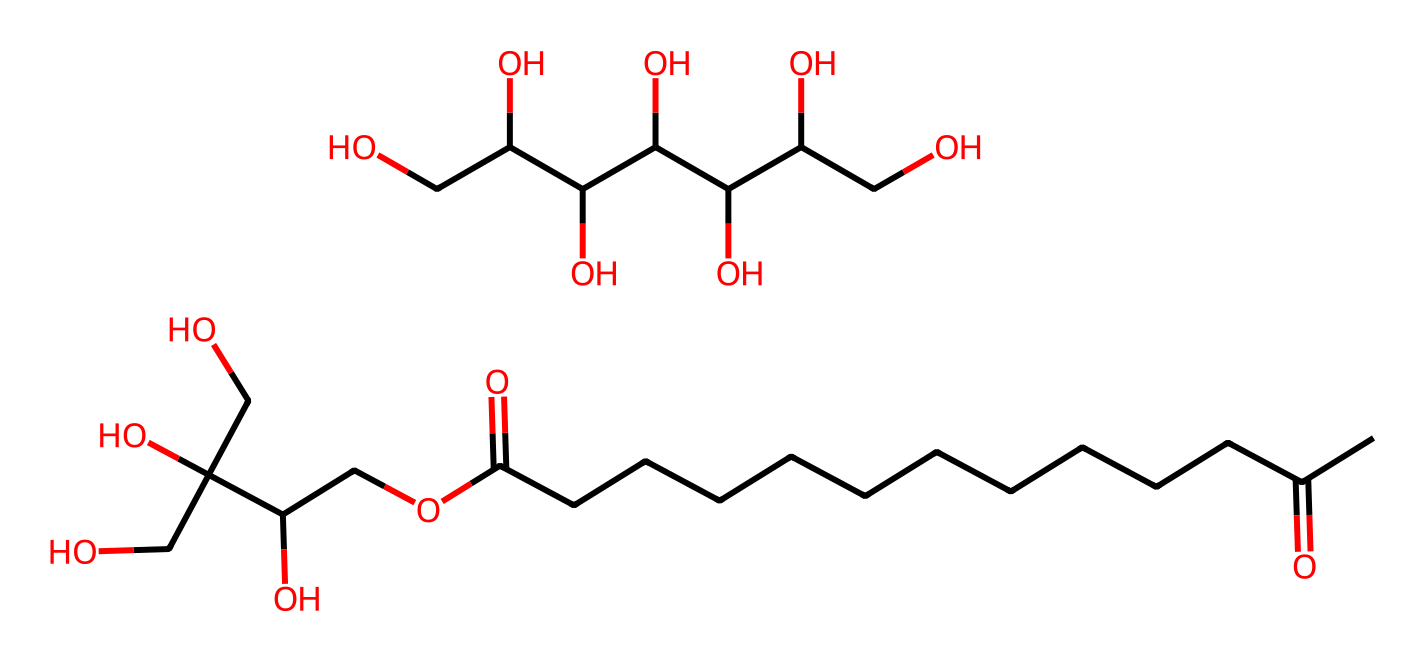What is the main functional group present in polysorbate 20? The structure contains multiple hydroxyl (OH) groups and ester functional groups, which are indicative of a polysorbate. The presence of these groups is critical for its surfactant properties.
Answer: hydroxyl and ester How many carbon atoms are in the primary hydrocarbon chain? Analyzing the structure reveals 11 carbon atoms in the long hydrocarbon chain, which is characteristic of surfactants that help reduce surface tension.
Answer: 11 What is the total number of oxygen atoms in this molecule? By examining the chemical structure, there are seven oxygen atoms identified: six from hydroxyl groups and one from the ester functional group.
Answer: seven What type of surfactant is polysorbate 20 classified as? Polysorbate 20 is classified based on its ability to stabilize emulsions and foams due to the presence of both hydrophilic and hydrophobic regions in its molecular structure.
Answer: nonionic How does the presence of multiple hydroxyl groups affect the solubility of polysorbate 20? Multiple hydroxyl groups provide strong hydrophilic characteristics, allowing polysorbate 20 to dissolve well in water, thereby enhancing its effectiveness as a surfactant.
Answer: increased solubility What role does the hydrophobic tail of polysorbate 20 play in its function as a surfactant? The hydrophobic tail reduces surface tension and stabilizes emulsions by orienting itself away from water, which is essential for creating stable fog outputs in machines.
Answer: stabilizes emulsions 